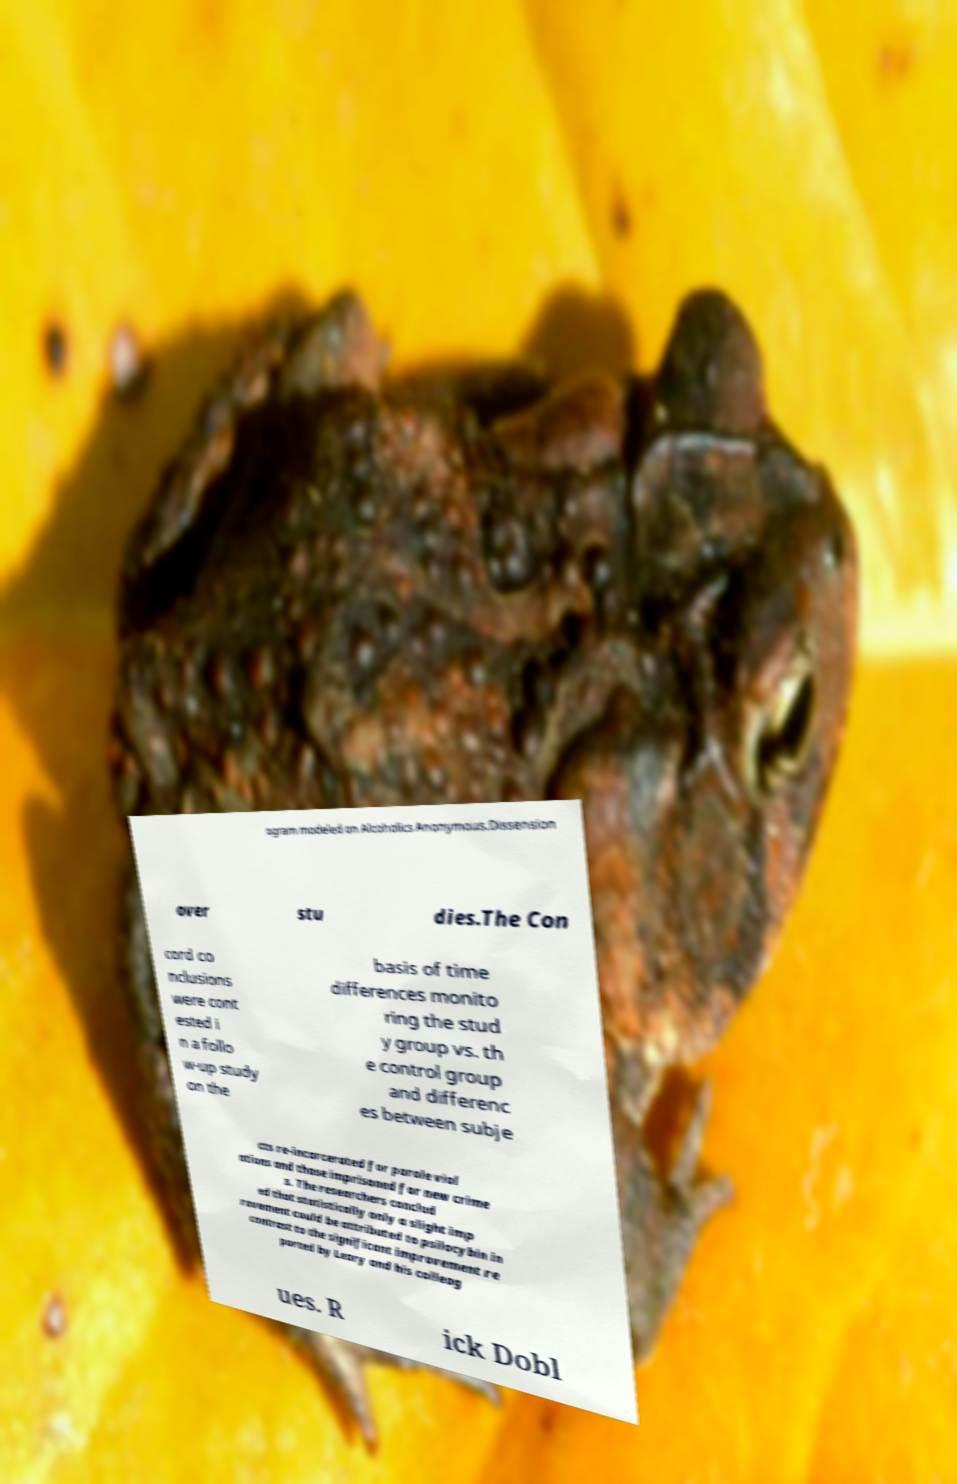Could you extract and type out the text from this image? ogram modeled on Alcoholics Anonymous.Dissension over stu dies.The Con cord co nclusions were cont ested i n a follo w-up study on the basis of time differences monito ring the stud y group vs. th e control group and differenc es between subje cts re-incarcerated for parole viol ations and those imprisoned for new crime s. The researchers conclud ed that statistically only a slight imp rovement could be attributed to psilocybin in contrast to the significant improvement re ported by Leary and his colleag ues. R ick Dobl 